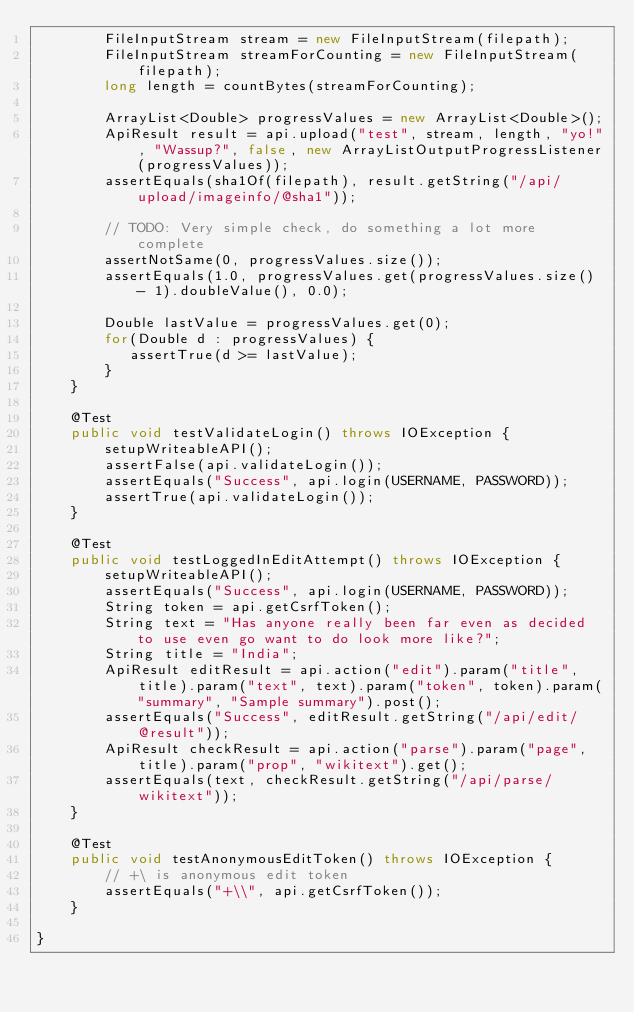Convert code to text. <code><loc_0><loc_0><loc_500><loc_500><_Java_>        FileInputStream stream = new FileInputStream(filepath);
        FileInputStream streamForCounting = new FileInputStream(filepath);
        long length = countBytes(streamForCounting);
        
        ArrayList<Double> progressValues = new ArrayList<Double>();
        ApiResult result = api.upload("test", stream, length, "yo!", "Wassup?", false, new ArrayListOutputProgressListener(progressValues));
        assertEquals(sha1Of(filepath), result.getString("/api/upload/imageinfo/@sha1"));
        
        // TODO: Very simple check, do something a lot more complete
        assertNotSame(0, progressValues.size());
        assertEquals(1.0, progressValues.get(progressValues.size() - 1).doubleValue(), 0.0);
       
        Double lastValue = progressValues.get(0);
        for(Double d : progressValues) {
           assertTrue(d >= lastValue); 
        }
    }

    @Test
    public void testValidateLogin() throws IOException {
        setupWriteableAPI();
        assertFalse(api.validateLogin());
        assertEquals("Success", api.login(USERNAME, PASSWORD));
        assertTrue(api.validateLogin());
    }
    
    @Test
    public void testLoggedInEditAttempt() throws IOException {
        setupWriteableAPI();
        assertEquals("Success", api.login(USERNAME, PASSWORD));
        String token = api.getCsrfToken();
        String text = "Has anyone really been far even as decided to use even go want to do look more like?";
        String title = "India";
        ApiResult editResult = api.action("edit").param("title", title).param("text", text).param("token", token).param("summary", "Sample summary").post();
        assertEquals("Success", editResult.getString("/api/edit/@result"));
        ApiResult checkResult = api.action("parse").param("page", title).param("prop", "wikitext").get();
        assertEquals(text, checkResult.getString("/api/parse/wikitext"));
    }

    @Test
    public void testAnonymousEditToken() throws IOException {
        // +\ is anonymous edit token
        assertEquals("+\\", api.getCsrfToken());
    }

}
</code> 